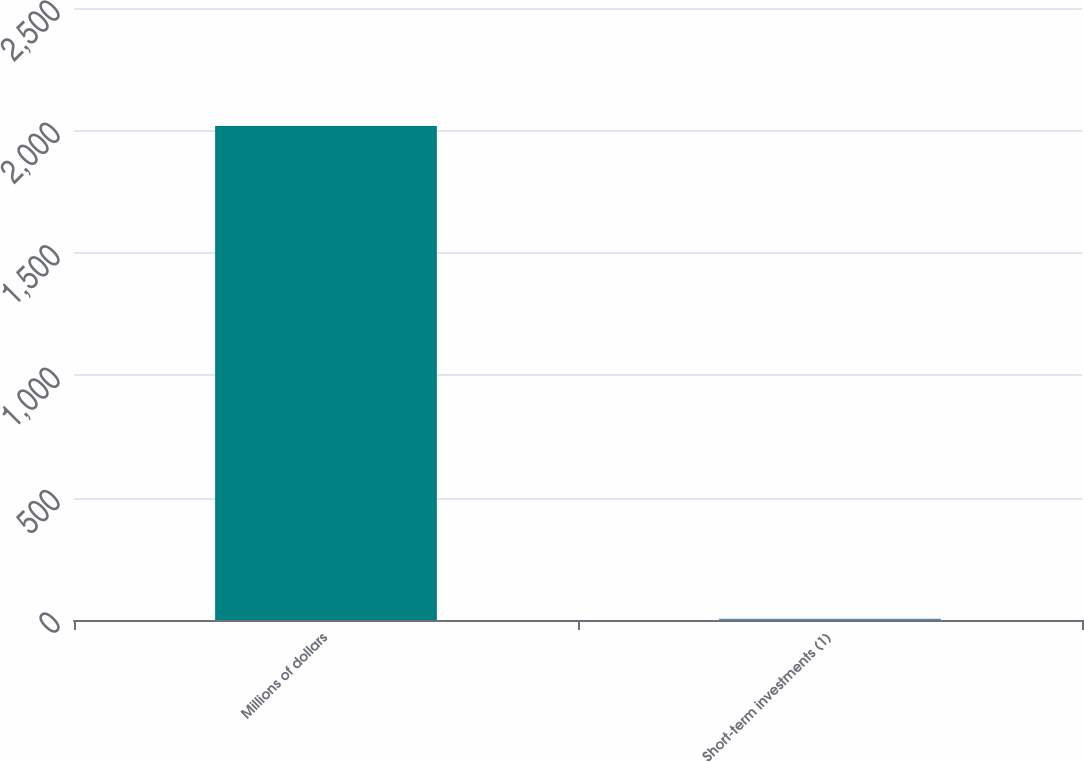Convert chart to OTSL. <chart><loc_0><loc_0><loc_500><loc_500><bar_chart><fcel>Millions of dollars<fcel>Short-term investments (1)<nl><fcel>2018<fcel>5<nl></chart> 